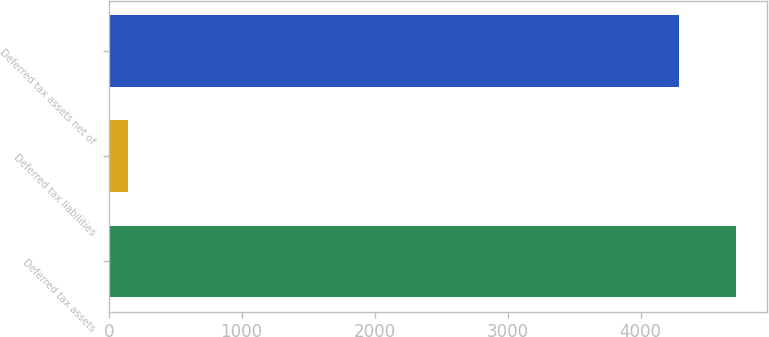Convert chart to OTSL. <chart><loc_0><loc_0><loc_500><loc_500><bar_chart><fcel>Deferred tax assets<fcel>Deferred tax liabilities<fcel>Deferred tax assets net of<nl><fcel>4715.7<fcel>143<fcel>4287<nl></chart> 